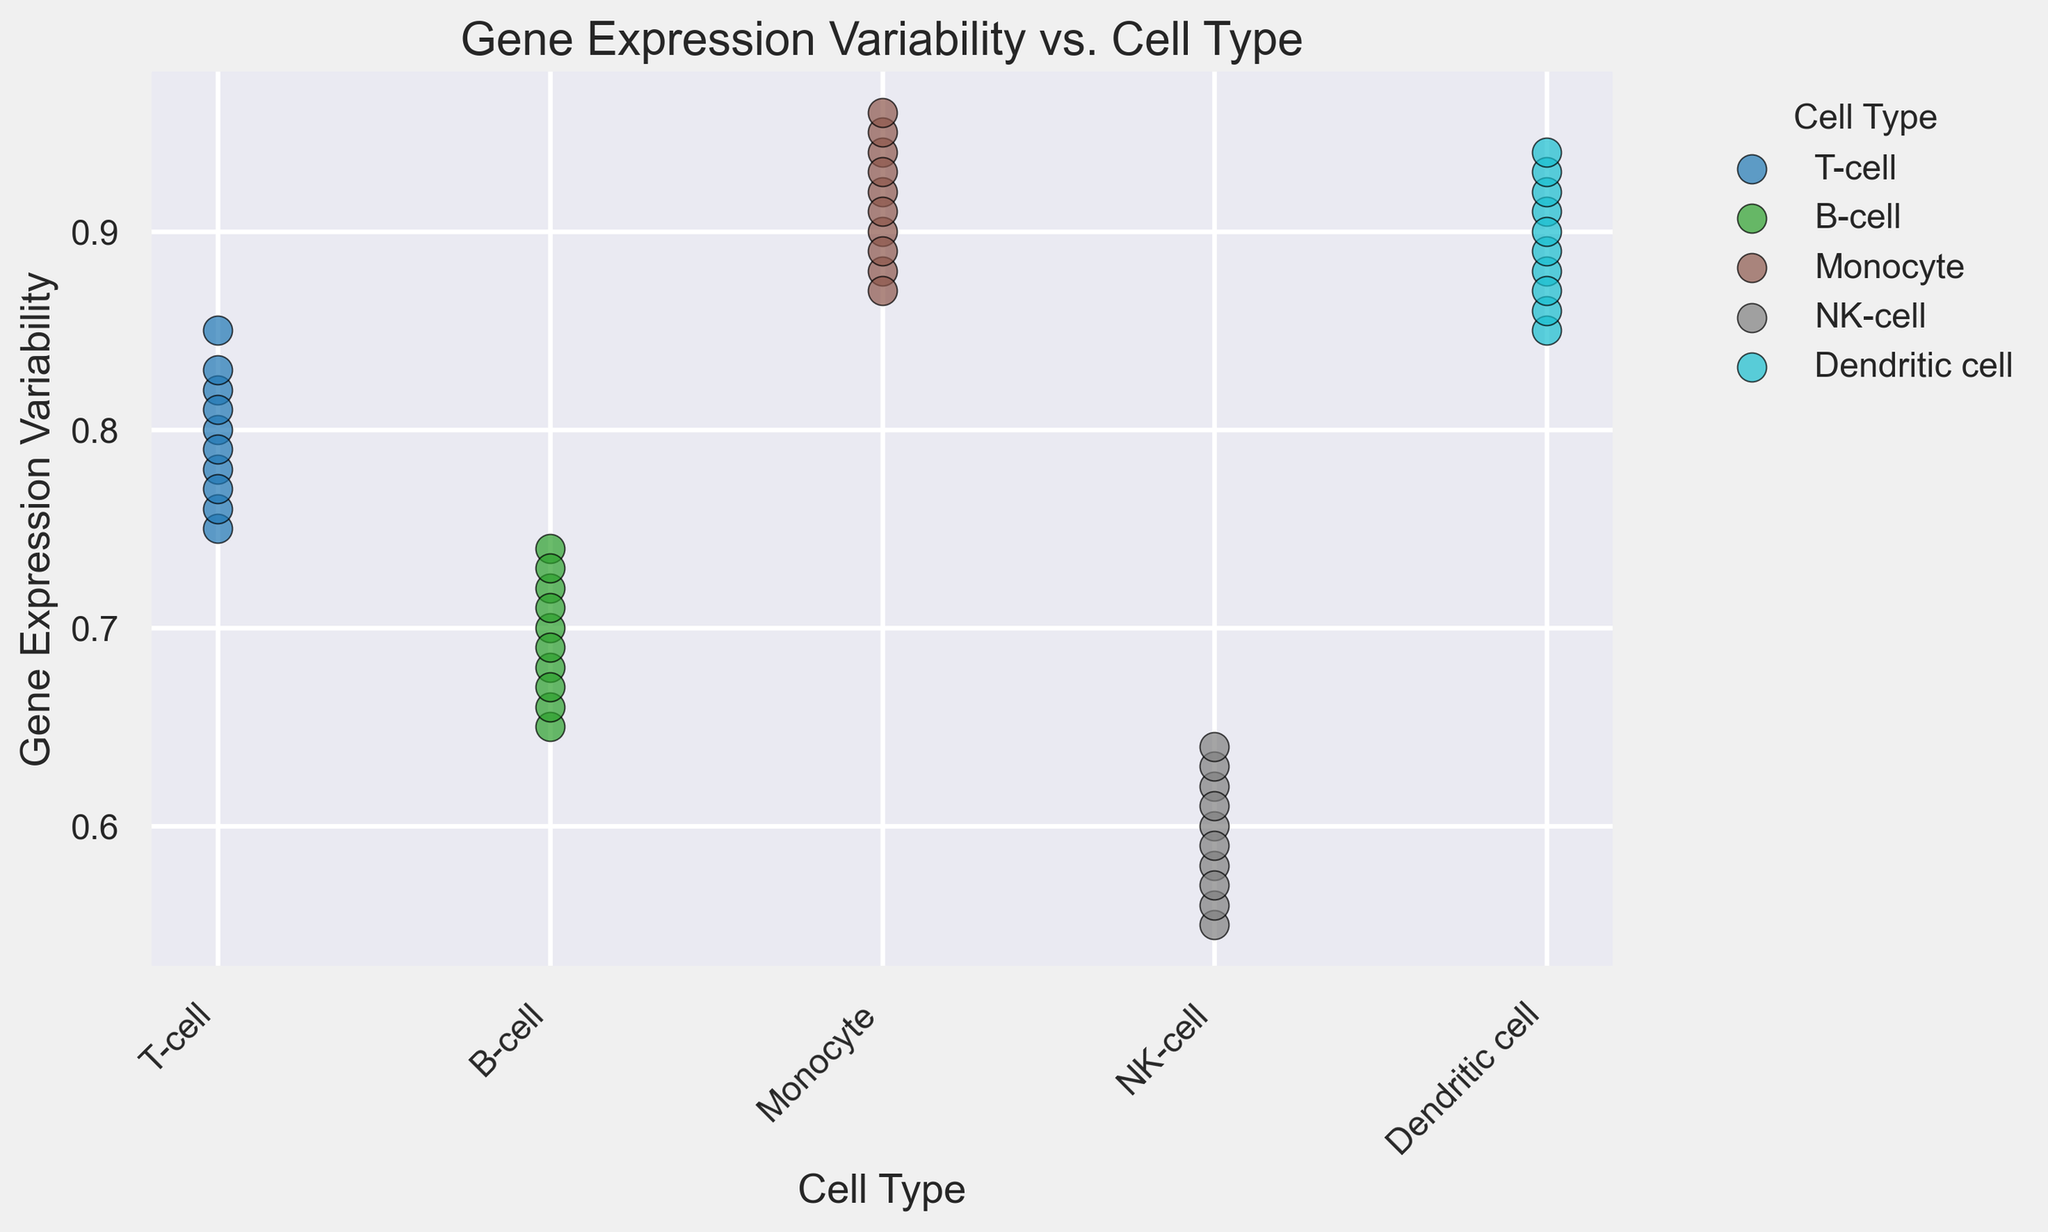What's the cell type with the highest gene expression variability on average? To find the cell type with the highest average gene expression variability, we need to calculate the average variability for each cell type, then compare them. For T-cell: (0.75+0.80+0.78+0.76+0.77+0.85+0.82+0.79+0.83+0.81)/10 = 0.796. For B-cell: (0.65+0.70+0.68+0.66+0.67+0.72+0.69+0.74+0.71+0.73)/10 = 0.695. For Monocyte: (0.90+0.92+0.91+0.88+0.89+0.94+0.93+0.95+0.87+0.96)/10 = 0.915. For NK-cell: (0.55+0.60+0.58+0.56+0.57+0.62+0.59+0.61+0.63+0.64)/10 = 0.595. For Dendritic cell: (0.85+0.88+0.86+0.87+0.89+0.91+0.92+0.93+0.90+0.94)/10 = 0.895. Comparing these averages, Monocyte has the highest average variability.
Answer: Monocyte Which cell type has the widest range of gene expression variability? To determine which cell type has the widest range, we calculate the range (max - min) of gene expression variability for each cell type. For T-cell: 0.85 - 0.75 = 0.10. For B-cell: 0.74 - 0.65 = 0.09. For Monocyte: 0.96 - 0.87 = 0.09. For NK-cell: 0.64 - 0.55 = 0.09. For Dendritic cell: 0.94 - 0.85 = 0.09. Comparing the ranges, T-cell has the widest range of gene expression variability.
Answer: T-cell Is there a cell type whose gene expression variabilities lie entirely above 0.70? To answer this, we need to check if the minimum gene expression variability for each cell type is above 0.70. T-cell: min=0.75, B-cell: min=0.65, Monocyte: min=0.87, NK-cell: min=0.55, Dendritic cell: min=0.85. Only Monocyte and Dendritic cell have minimum values entirely above 0.70.
Answer: Monocyte and Dendritic cell Compare the gene expression variability of T-cells and NK-cells. Which one is more consistent? Consistency can be measured by the range (difference between max and min) of gene expression variability. T-cell: range=0.85 - 0.75 = 0.10. NK-cell: range=0.64 - 0.55 = 0.09. NK-cells have a smaller range, suggesting more consistency in gene expression variability compared to T-cells.
Answer: NK-cell Among the cell types, which one shows the most uniform distribution of gene expression variability in the figure? Uniform distribution implies a smaller standard deviation among the values. We can visually estimate this from the scatterplot by observing the spread of dots. Monocytes and Dendritic cells appear to have a tight cluster, suggesting uniform distribution. However, Monocyte values are slightly more broadly distributed compared to Dendritic cells.
Answer: Dendritic cell Which cell type has the lowest maximum gene expression variability? To find this, we need to check the maximum value for each cell type. T-cell: max=0.85, B-cell: max=0.74, Monocyte: max=0.96, NK-cell: max=0.64, Dendritic cell: max=0.94. Thus, the B-cell has the lowest maximum gene expression variability.
Answer: B-cell What is the median gene expression variability for NK-cells? To calculate the median for NK-cells: sort the values (0.55, 0.56, 0.57, 0.58, 0.59, 0.60, 0.61, 0.62, 0.63, 0.64), then find the middle values. The median is the average of 0.59 and 0.60, which is (0.59 + 0.60)/2 = 0.595. The median variability for NK-cells is 0.595.
Answer: 0.595 